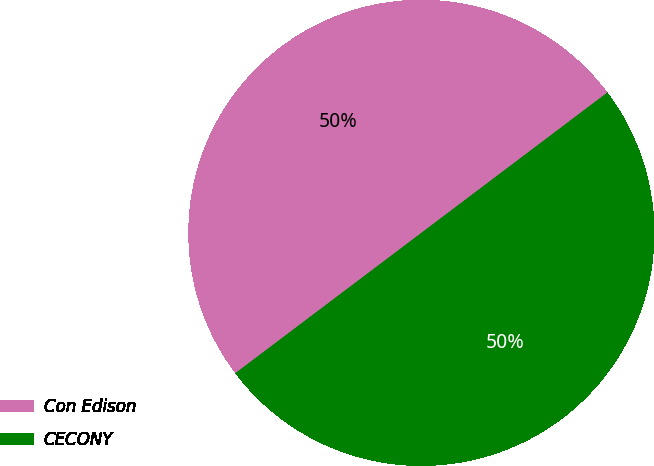Convert chart. <chart><loc_0><loc_0><loc_500><loc_500><pie_chart><fcel>Con Edison<fcel>CECONY<nl><fcel>50.0%<fcel>50.0%<nl></chart> 